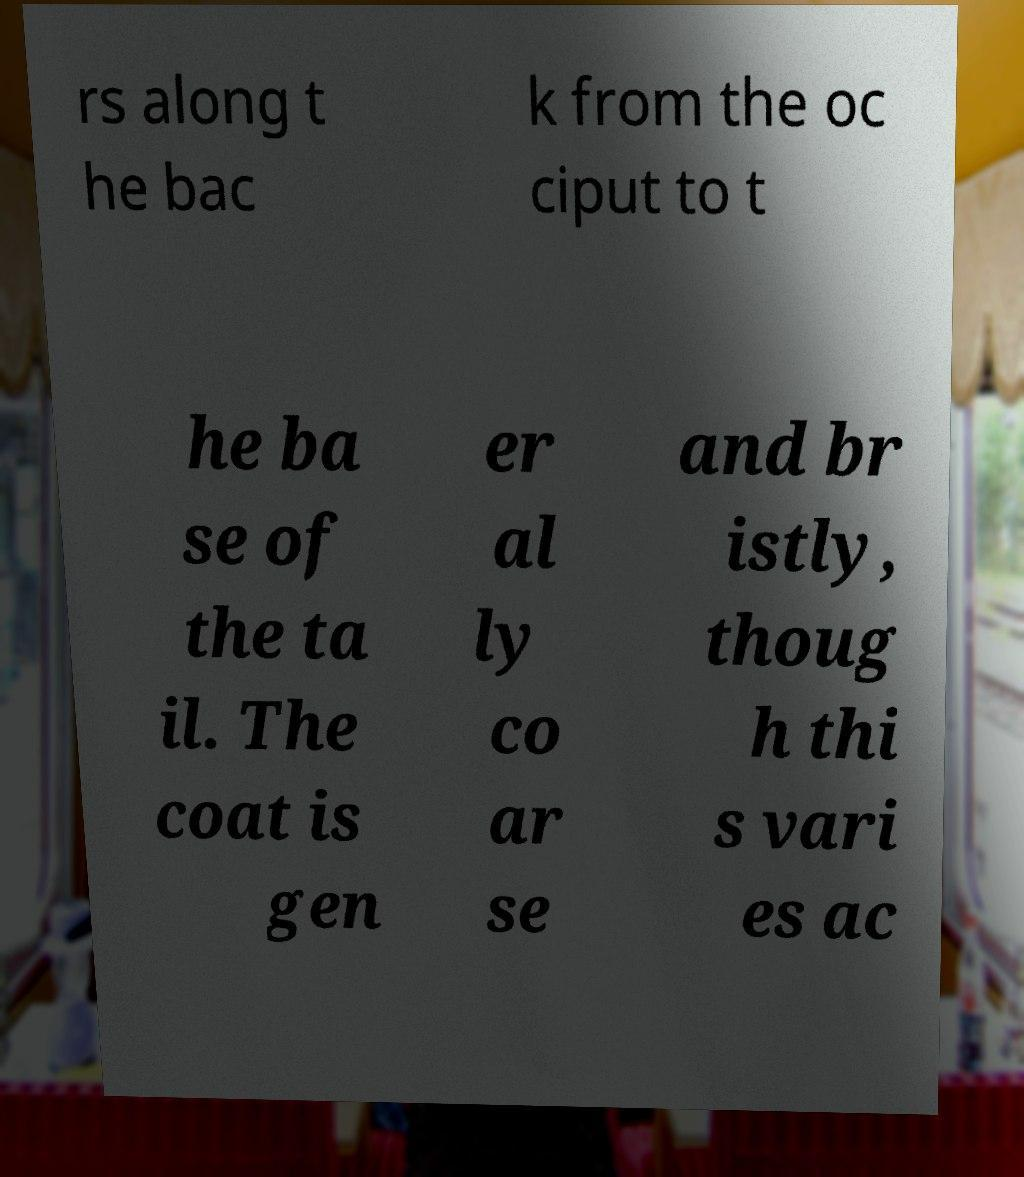There's text embedded in this image that I need extracted. Can you transcribe it verbatim? rs along t he bac k from the oc ciput to t he ba se of the ta il. The coat is gen er al ly co ar se and br istly, thoug h thi s vari es ac 